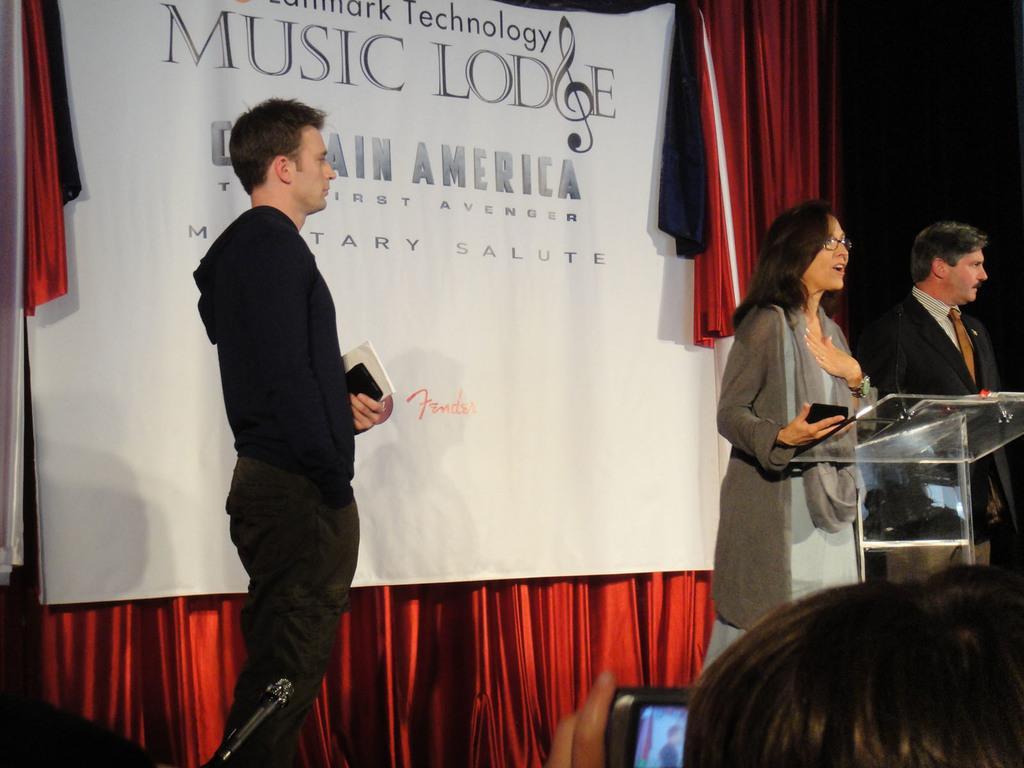How would you summarize this image in a sentence or two? In this image there is a man on the left side who is holding the book and a mobile. ON the right side there is a glass podium in front of the woman. In the background there is a banner which is in front of the curtains. At the bottom there is a person who is taking the picture with the camera. On the right side there is another person beside the girl. 